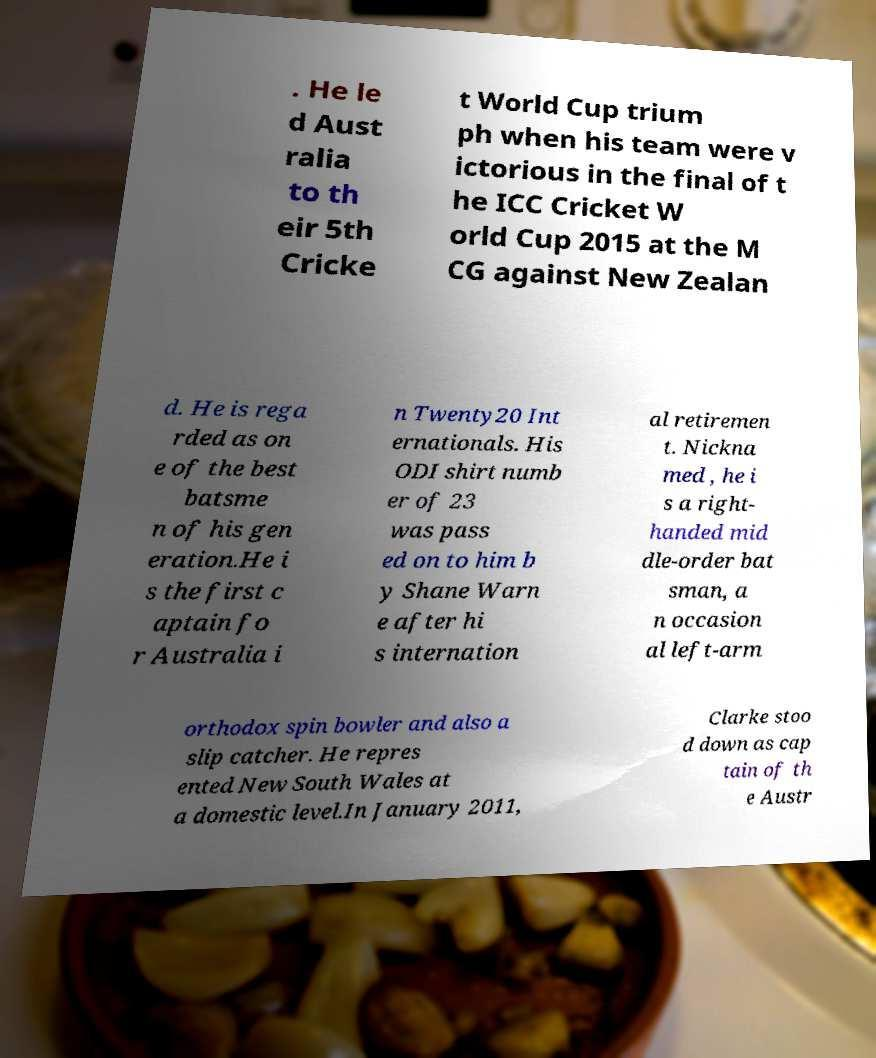Please read and relay the text visible in this image. What does it say? . He le d Aust ralia to th eir 5th Cricke t World Cup trium ph when his team were v ictorious in the final of t he ICC Cricket W orld Cup 2015 at the M CG against New Zealan d. He is rega rded as on e of the best batsme n of his gen eration.He i s the first c aptain fo r Australia i n Twenty20 Int ernationals. His ODI shirt numb er of 23 was pass ed on to him b y Shane Warn e after hi s internation al retiremen t. Nickna med , he i s a right- handed mid dle-order bat sman, a n occasion al left-arm orthodox spin bowler and also a slip catcher. He repres ented New South Wales at a domestic level.In January 2011, Clarke stoo d down as cap tain of th e Austr 